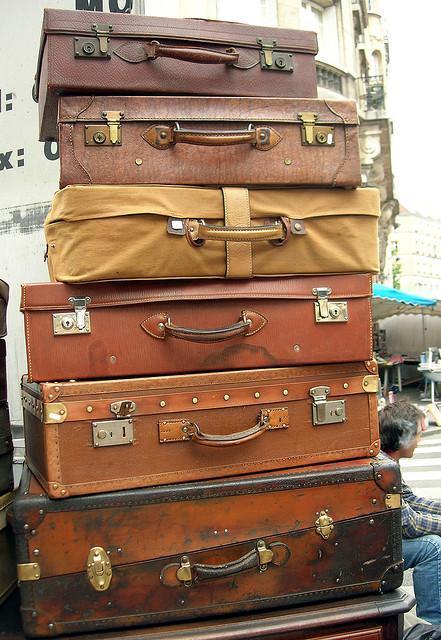What is the building at the back?
Choose the right answer and clarify with the format: 'Answer: answer
Rationale: rationale.'
Options: Shopping mall, residential building, hotel, office building. Answer: hotel.
Rationale: The building can be seen as tall with many windows. the luggage in front of it indicates that it will be brought inside by travelers who are staying there. 